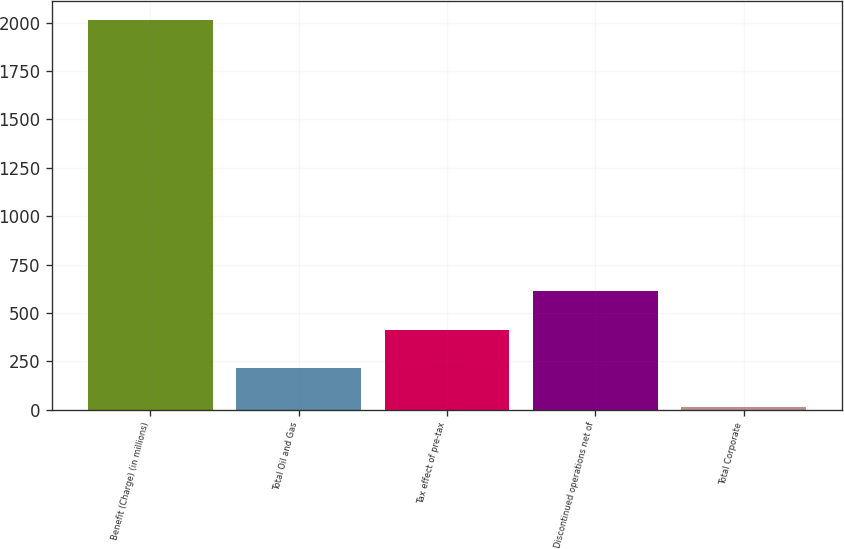<chart> <loc_0><loc_0><loc_500><loc_500><bar_chart><fcel>Benefit (Charge) (in millions)<fcel>Total Oil and Gas<fcel>Tax effect of pre-tax<fcel>Discontinued operations net of<fcel>Total Corporate<nl><fcel>2011<fcel>214.6<fcel>414.2<fcel>613.8<fcel>15<nl></chart> 